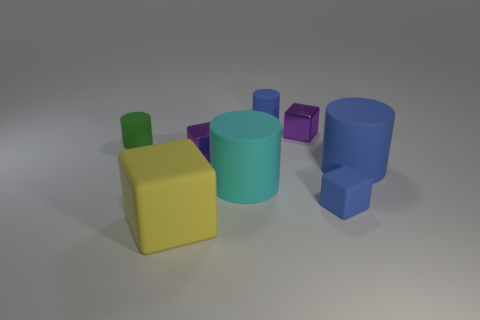Subtract all tiny blue cylinders. How many cylinders are left? 3 Add 2 big rubber cylinders. How many objects exist? 10 Subtract 4 cubes. How many cubes are left? 0 Subtract all cyan cylinders. How many cylinders are left? 3 Subtract 0 brown cylinders. How many objects are left? 8 Subtract all cyan cylinders. Subtract all yellow blocks. How many cylinders are left? 3 Subtract all yellow balls. How many gray cylinders are left? 0 Subtract all green things. Subtract all matte things. How many objects are left? 1 Add 1 tiny blue things. How many tiny blue things are left? 3 Add 4 small cyan matte cylinders. How many small cyan matte cylinders exist? 4 